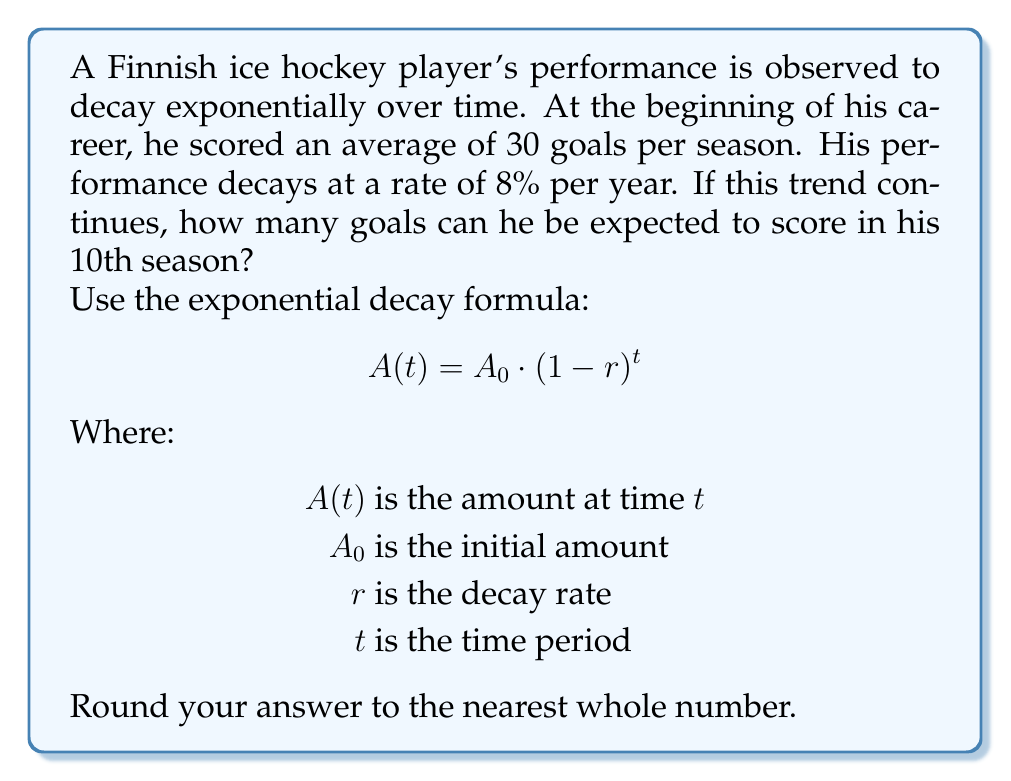Show me your answer to this math problem. To solve this problem, we'll use the exponential decay formula:

$$A(t) = A_0 \cdot (1-r)^t$$

Given:
$A_0 = 30$ (initial goals per season)
$r = 0.08$ (8% decay rate)
$t = 10$ (10th season)

Let's substitute these values into the formula:

$$A(10) = 30 \cdot (1-0.08)^{10}$$

Now, let's calculate step by step:

1) First, calculate $(1-0.08)$:
   $1 - 0.08 = 0.92$

2) Now, we have:
   $$A(10) = 30 \cdot (0.92)^{10}$$

3) Calculate $(0.92)^{10}$:
   $(0.92)^{10} \approx 0.4338$ (rounded to 4 decimal places)

4) Finally, multiply:
   $$A(10) = 30 \cdot 0.4338 \approx 13.014$$

5) Rounding to the nearest whole number:
   $13.014 \approx 13$

Therefore, in his 10th season, the player can be expected to score approximately 13 goals.
Answer: 13 goals 